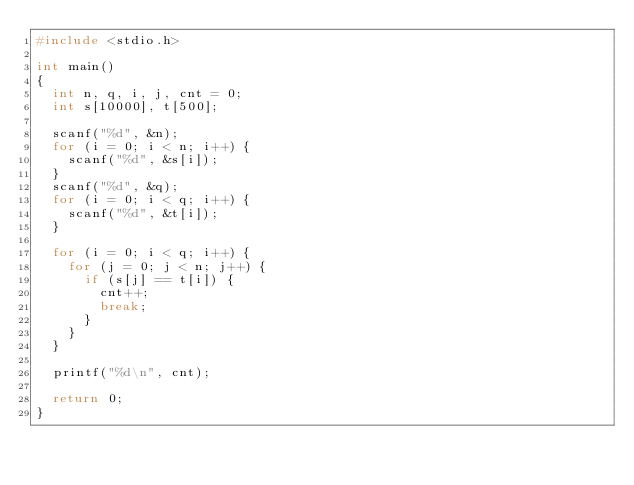<code> <loc_0><loc_0><loc_500><loc_500><_C_>#include <stdio.h>

int main()
{
  int n, q, i, j, cnt = 0;
  int s[10000], t[500];

  scanf("%d", &n);
  for (i = 0; i < n; i++) {
    scanf("%d", &s[i]);
  }
  scanf("%d", &q);
  for (i = 0; i < q; i++) {
    scanf("%d", &t[i]);
  }

  for (i = 0; i < q; i++) {
    for (j = 0; j < n; j++) {
      if (s[j] == t[i]) {
        cnt++;
        break;
      }
    }
  }

  printf("%d\n", cnt);

  return 0;
}</code> 